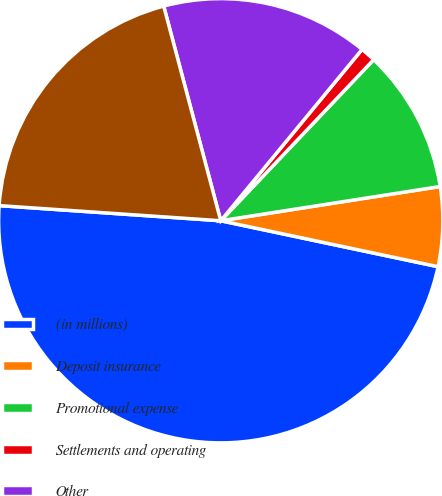Convert chart to OTSL. <chart><loc_0><loc_0><loc_500><loc_500><pie_chart><fcel>(in millions)<fcel>Deposit insurance<fcel>Promotional expense<fcel>Settlements and operating<fcel>Other<fcel>Other operating expense<nl><fcel>47.77%<fcel>5.78%<fcel>10.45%<fcel>1.11%<fcel>15.11%<fcel>19.78%<nl></chart> 